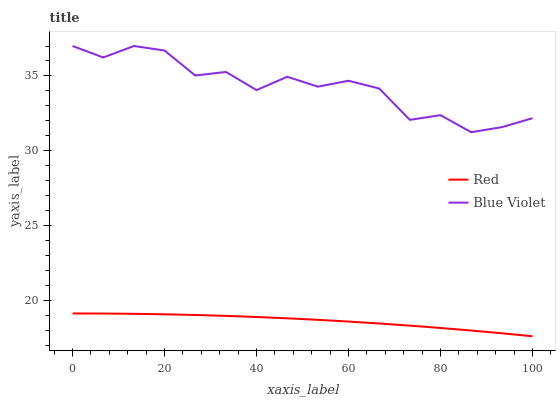Does Red have the minimum area under the curve?
Answer yes or no. Yes. Does Blue Violet have the maximum area under the curve?
Answer yes or no. Yes. Does Red have the maximum area under the curve?
Answer yes or no. No. Is Red the smoothest?
Answer yes or no. Yes. Is Blue Violet the roughest?
Answer yes or no. Yes. Is Red the roughest?
Answer yes or no. No. Does Red have the lowest value?
Answer yes or no. Yes. Does Blue Violet have the highest value?
Answer yes or no. Yes. Does Red have the highest value?
Answer yes or no. No. Is Red less than Blue Violet?
Answer yes or no. Yes. Is Blue Violet greater than Red?
Answer yes or no. Yes. Does Red intersect Blue Violet?
Answer yes or no. No. 